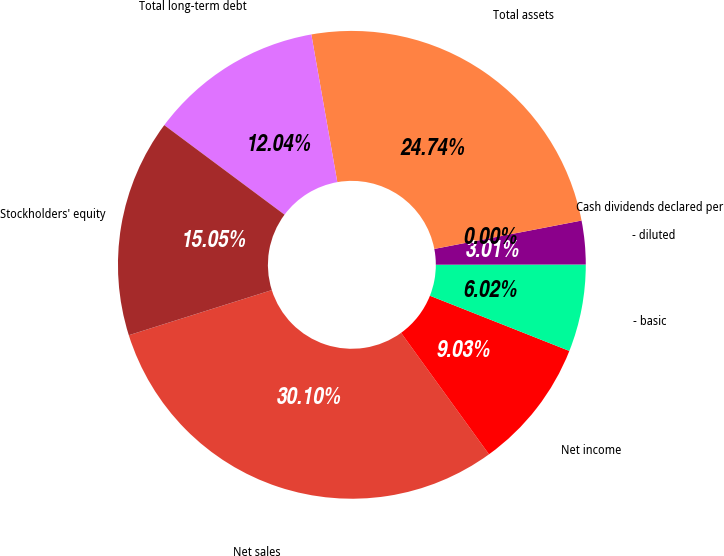Convert chart. <chart><loc_0><loc_0><loc_500><loc_500><pie_chart><fcel>Net sales<fcel>Net income<fcel>- basic<fcel>- diluted<fcel>Cash dividends declared per<fcel>Total assets<fcel>Total long-term debt<fcel>Stockholders' equity<nl><fcel>30.1%<fcel>9.03%<fcel>6.02%<fcel>3.01%<fcel>0.0%<fcel>24.74%<fcel>12.04%<fcel>15.05%<nl></chart> 